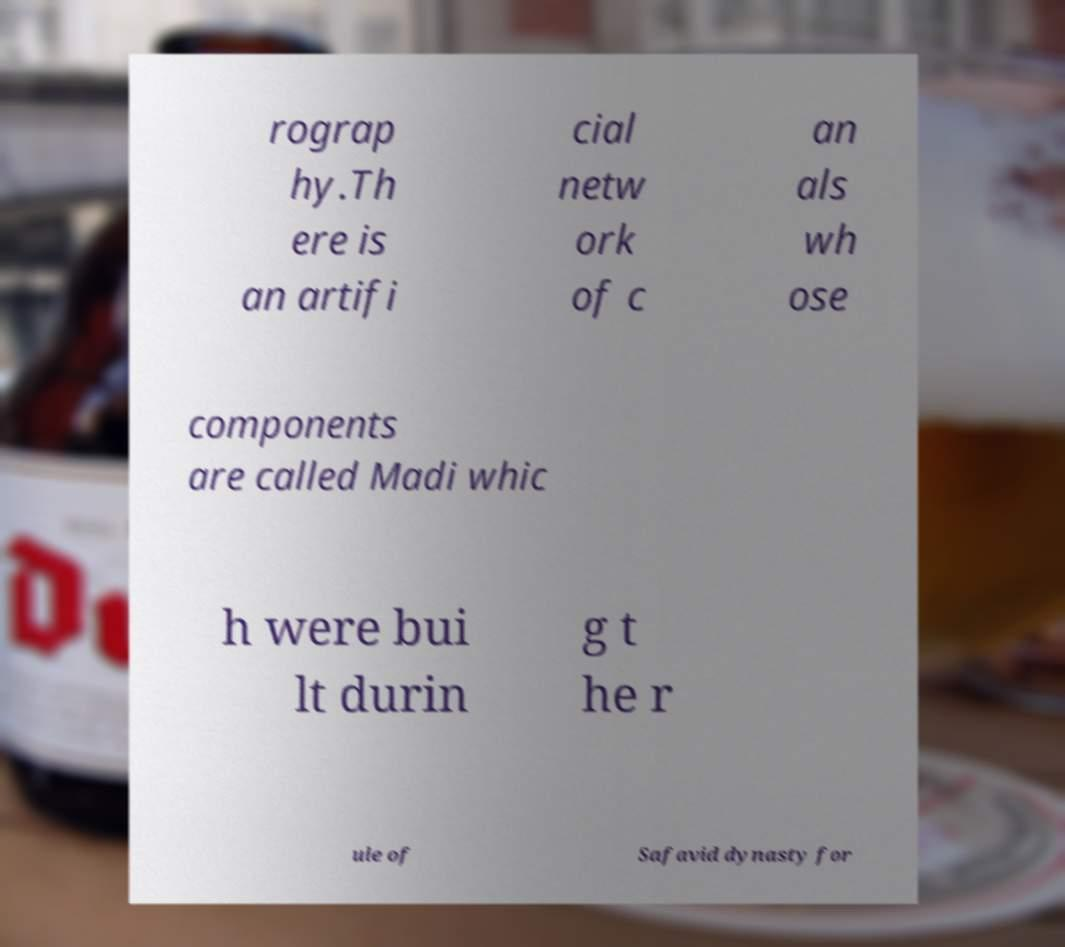Can you read and provide the text displayed in the image?This photo seems to have some interesting text. Can you extract and type it out for me? rograp hy.Th ere is an artifi cial netw ork of c an als wh ose components are called Madi whic h were bui lt durin g t he r ule of Safavid dynasty for 